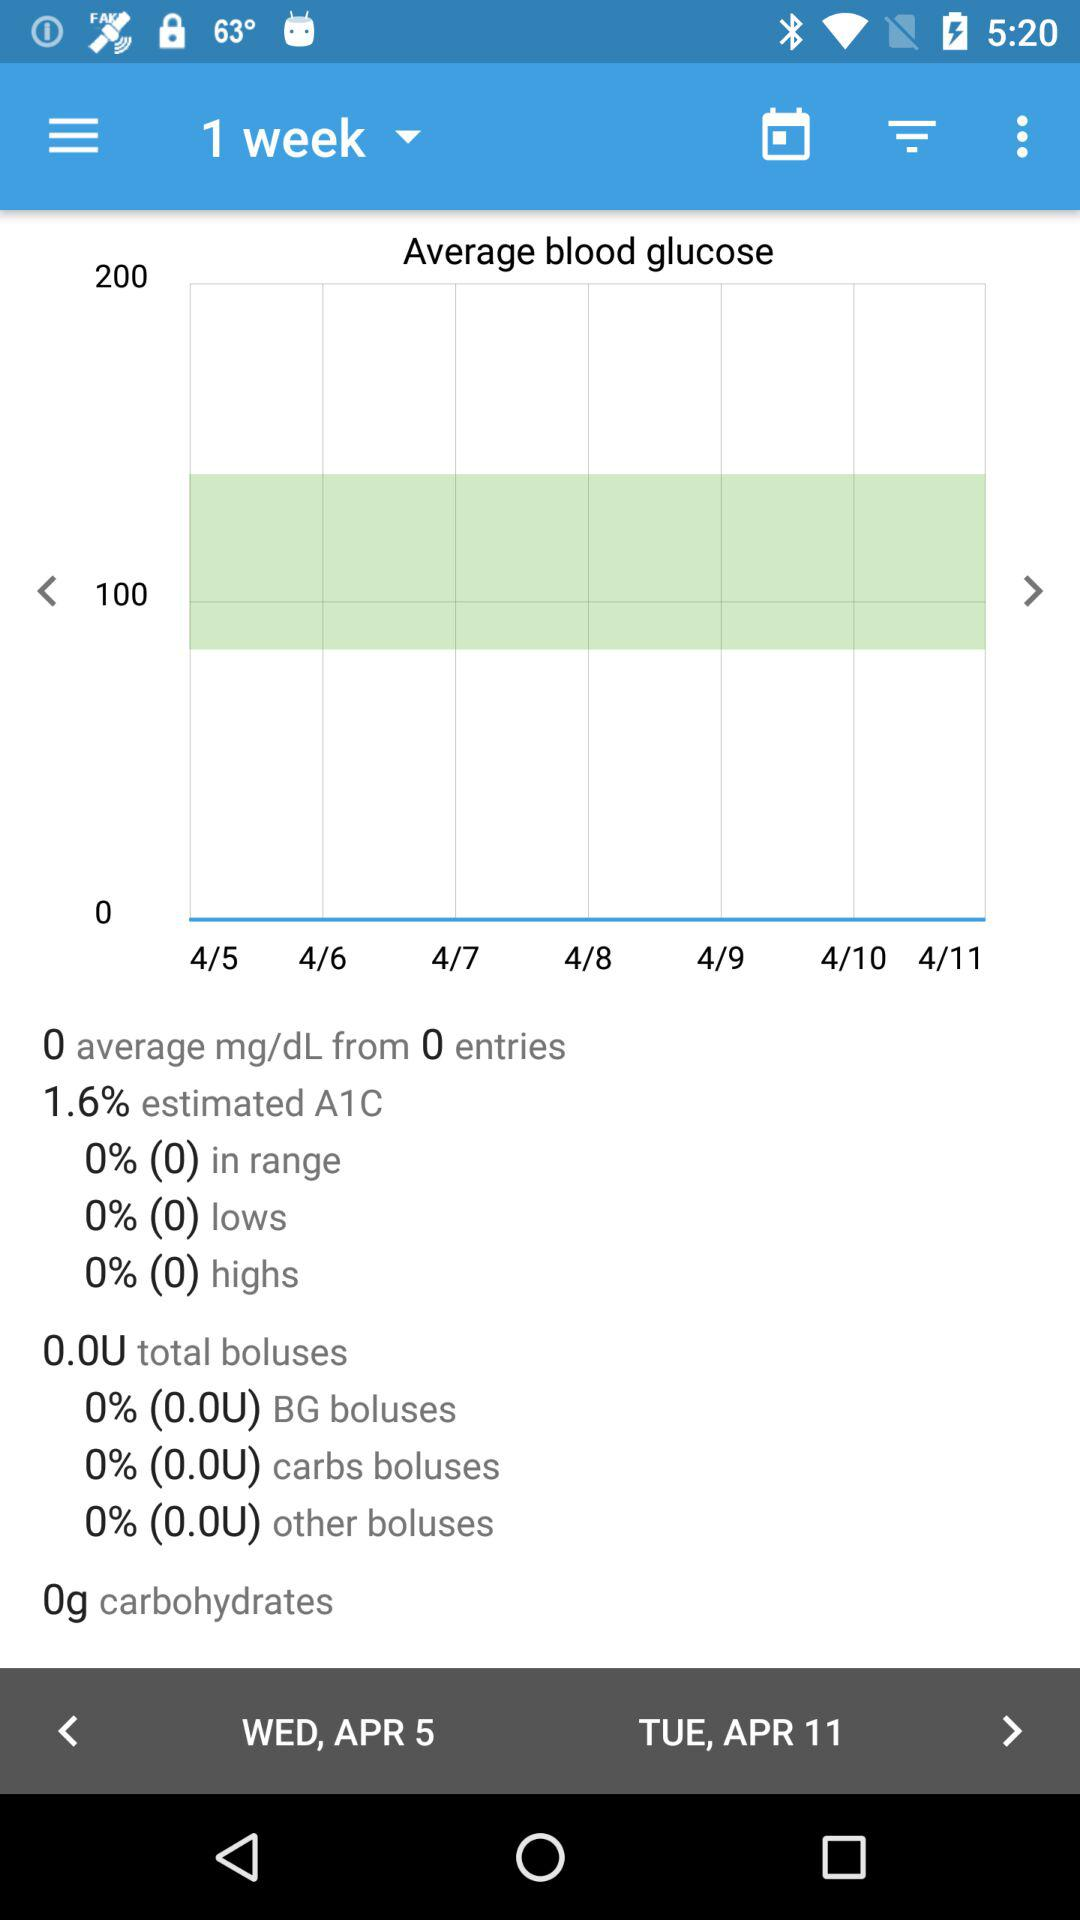How much is the estimated A1C? The estimated A1C is 1.6%. 